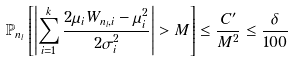<formula> <loc_0><loc_0><loc_500><loc_500>\mathbb { P } _ { n _ { l } } \left [ \left | \sum _ { i = 1 } ^ { k } \frac { 2 \mu _ { i } W _ { n _ { l } , i } - \mu _ { i } ^ { 2 } } { 2 \sigma _ { i } ^ { 2 } } \right | > M \right ] \leq \frac { C ^ { \prime } } { M ^ { 2 } } \leq \frac { \delta } { 1 0 0 }</formula> 